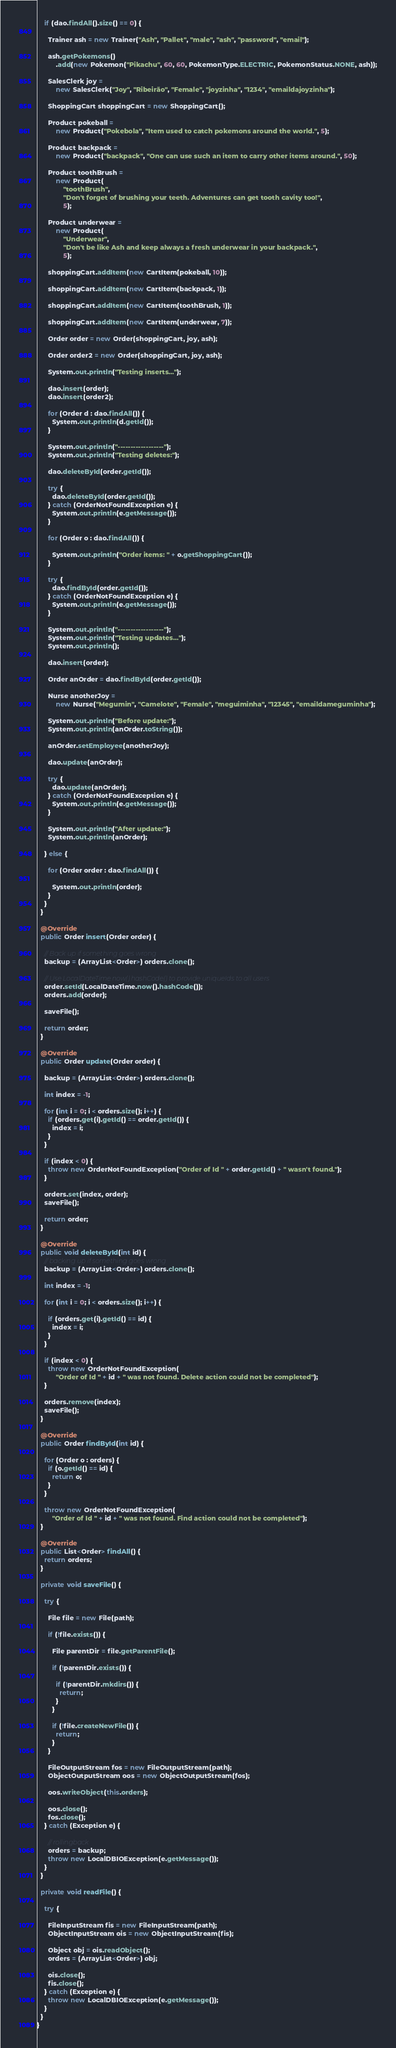Convert code to text. <code><loc_0><loc_0><loc_500><loc_500><_Java_>    if (dao.findAll().size() == 0) {

      Trainer ash = new Trainer("Ash", "Pallet", "male", "ash", "password", "email");

      ash.getPokemons()
          .add(new Pokemon("Pikachu", 60, 60, PokemonType.ELECTRIC, PokemonStatus.NONE, ash));

      SalesClerk joy =
          new SalesClerk("Joy", "Ribeirão", "Female", "joyzinha", "1234", "emaildajoyzinha");

      ShoppingCart shoppingCart = new ShoppingCart();

      Product pokeball =
          new Product("Pokebola", "Item used to catch pokemons around the world.", 5);

      Product backpack =
          new Product("backpack", "One can use such an item to carry other items around.", 50);

      Product toothBrush =
          new Product(
              "toothBrush",
              "Don't forget of brushing your teeth. Adventures can get tooth cavity too!",
              5);

      Product underwear =
          new Product(
              "Underwear",
              "Don't be like Ash and keep always a fresh underwear in your backpack.",
              5);

      shoppingCart.addItem(new CartItem(pokeball, 10));

      shoppingCart.addItem(new CartItem(backpack, 1));

      shoppingCart.addItem(new CartItem(toothBrush, 1));

      shoppingCart.addItem(new CartItem(underwear, 7));

      Order order = new Order(shoppingCart, joy, ash);

      Order order2 = new Order(shoppingCart, joy, ash);

      System.out.println("Testing inserts...");

      dao.insert(order);
      dao.insert(order2);

      for (Order d : dao.findAll()) {
        System.out.println(d.getId());
      }

      System.out.println("------------------");
      System.out.println("Testing deletes:");

      dao.deleteById(order.getId());

      try {
        dao.deleteById(order.getId());
      } catch (OrderNotFoundException e) {
        System.out.println(e.getMessage());
      }

      for (Order o : dao.findAll()) {

        System.out.println("Order items: " + o.getShoppingCart());
      }

      try {
        dao.findById(order.getId());
      } catch (OrderNotFoundException e) {
        System.out.println(e.getMessage());
      }

      System.out.println("------------------");
      System.out.println("Testing updates...");
      System.out.println();

      dao.insert(order);

      Order anOrder = dao.findById(order.getId());

      Nurse anotherJoy =
          new Nurse("Megumin", "Camelote", "Female", "meguiminha", "12345", "emaildameguminha");

      System.out.println("Before update:");
      System.out.println(anOrder.toString());

      anOrder.setEmployee(anotherJoy);

      dao.update(anOrder);

      try {
        dao.update(anOrder);
      } catch (OrderNotFoundException e) {
        System.out.println(e.getMessage());
      }

      System.out.println("After update:");
      System.out.println(anOrder);

    } else {

      for (Order order : dao.findAll()) {

        System.out.println(order);
      }
    }
  }

  @Override
  public Order insert(Order order) {

    // Back up if something goes wrong
    backup = (ArrayList<Order>) orders.clone();

    // Use LocalDateTime.now().hashCode() to provide uniqueIds to all users
    order.setId(LocalDateTime.now().hashCode());
    orders.add(order);

    saveFile();

    return order;
  }

  @Override
  public Order update(Order order) {

    backup = (ArrayList<Order>) orders.clone();

    int index = -1;

    for (int i = 0; i < orders.size(); i++) {
      if (orders.get(i).getId() == order.getId()) {
        index = i;
      }
    }

    if (index < 0) {
      throw new OrderNotFoundException("Order of Id " + order.getId() + " wasn't found.");
    }

    orders.set(index, order);
    saveFile();

    return order;
  }

  @Override
  public void deleteById(int id) {
    // backing up if something goes wrong
    backup = (ArrayList<Order>) orders.clone();

    int index = -1;

    for (int i = 0; i < orders.size(); i++) {

      if (orders.get(i).getId() == id) {
        index = i;
      }
    }

    if (index < 0) {
      throw new OrderNotFoundException(
          "Order of Id " + id + " was not found. Delete action could not be completed");
    }

    orders.remove(index);
    saveFile();
  }

  @Override
  public Order findById(int id) {

    for (Order o : orders) {
      if (o.getId() == id) {
        return o;
      }
    }

    throw new OrderNotFoundException(
        "Order of Id " + id + " was not found. Find action could not be completed");
  }

  @Override
  public List<Order> findAll() {
    return orders;
  }

  private void saveFile() {

    try {

      File file = new File(path);

      if (!file.exists()) {

        File parentDir = file.getParentFile();

        if (!parentDir.exists()) {

          if (!parentDir.mkdirs()) {
            return;
          }
        }

        if (!file.createNewFile()) {
          return;
        }
      }

      FileOutputStream fos = new FileOutputStream(path);
      ObjectOutputStream oos = new ObjectOutputStream(fos);

      oos.writeObject(this.orders);

      oos.close();
      fos.close();
    } catch (Exception e) {

      // rollingback
      orders = backup;
      throw new LocalDBIOException(e.getMessage());
    }
  }

  private void readFile() {

    try {

      FileInputStream fis = new FileInputStream(path);
      ObjectInputStream ois = new ObjectInputStream(fis);

      Object obj = ois.readObject();
      orders = (ArrayList<Order>) obj;

      ois.close();
      fis.close();
    } catch (Exception e) {
      throw new LocalDBIOException(e.getMessage());
    }
  }
}
</code> 